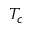Convert formula to latex. <formula><loc_0><loc_0><loc_500><loc_500>T _ { c }</formula> 